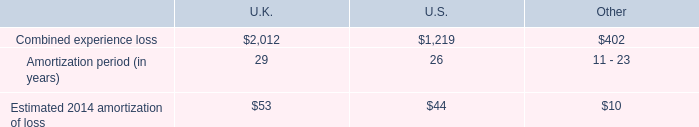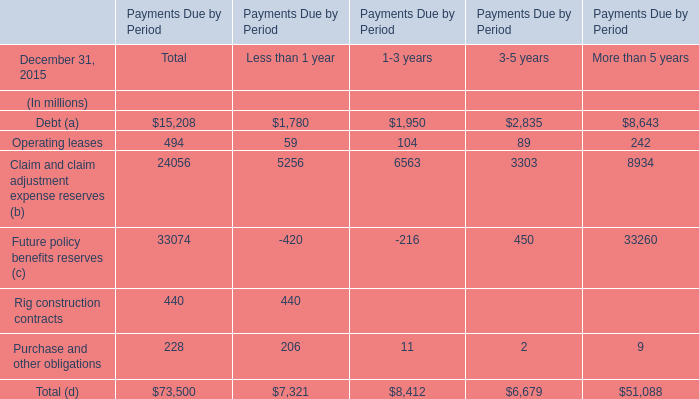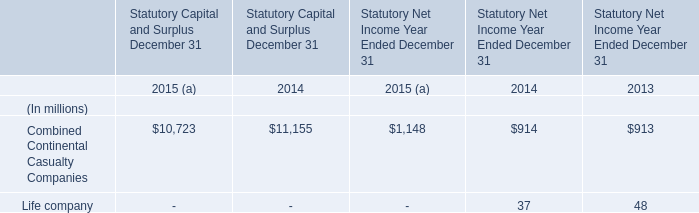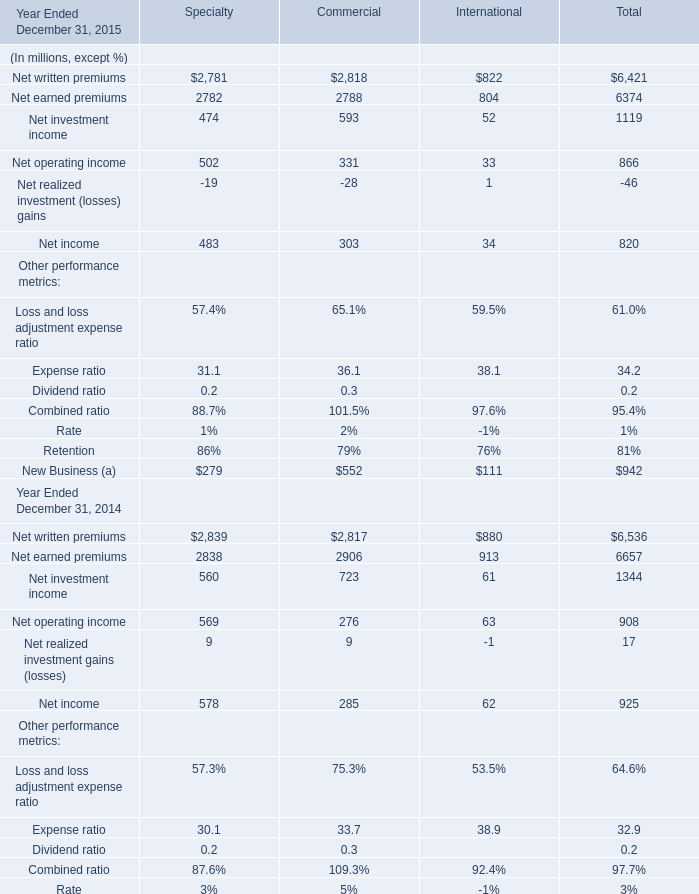What was the total amount of the Net income in the years where Net operating income for Total greater than 900? (in million) 
Computations: ((578 + 285) + 62)
Answer: 925.0. 